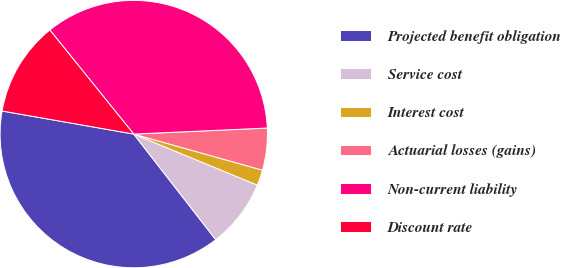<chart> <loc_0><loc_0><loc_500><loc_500><pie_chart><fcel>Projected benefit obligation<fcel>Service cost<fcel>Interest cost<fcel>Actuarial losses (gains)<fcel>Non-current liability<fcel>Discount rate<nl><fcel>38.27%<fcel>8.26%<fcel>1.88%<fcel>5.07%<fcel>35.08%<fcel>11.44%<nl></chart> 